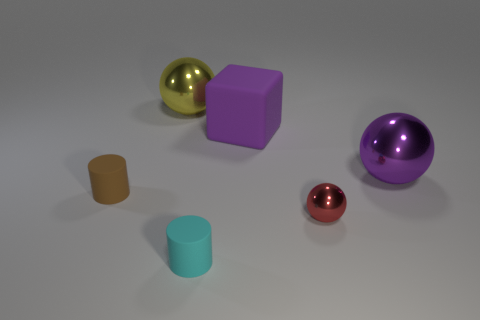Add 3 big purple metallic things. How many objects exist? 9 Subtract all cylinders. How many objects are left? 4 Subtract all small brown rubber cylinders. Subtract all small matte things. How many objects are left? 3 Add 1 tiny red spheres. How many tiny red spheres are left? 2 Add 3 tiny brown metal things. How many tiny brown metal things exist? 3 Subtract 0 gray cubes. How many objects are left? 6 